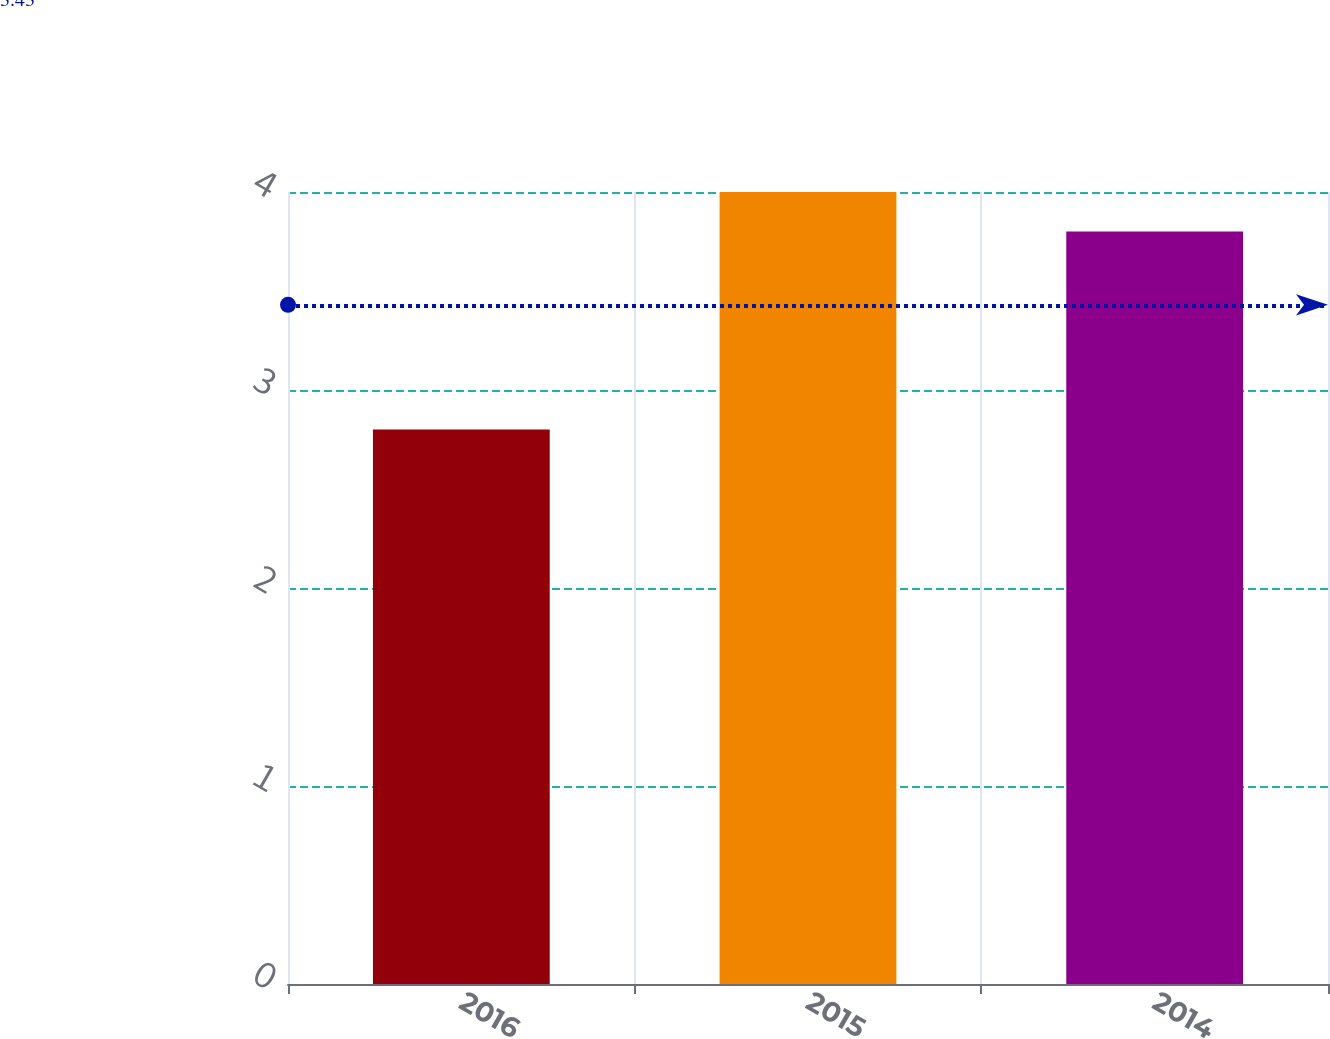<chart> <loc_0><loc_0><loc_500><loc_500><bar_chart><fcel>2016<fcel>2015<fcel>2014<nl><fcel>2.8<fcel>4<fcel>3.8<nl></chart> 